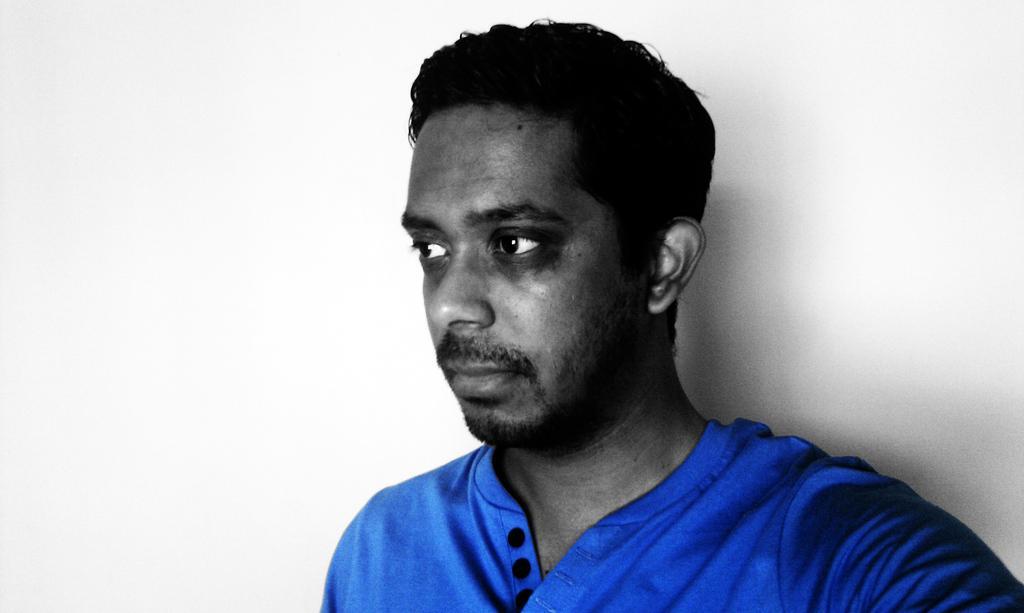How would you summarize this image in a sentence or two? In this picture there is a man who is wearing blue t-shirt. He is standing near to the wall. 